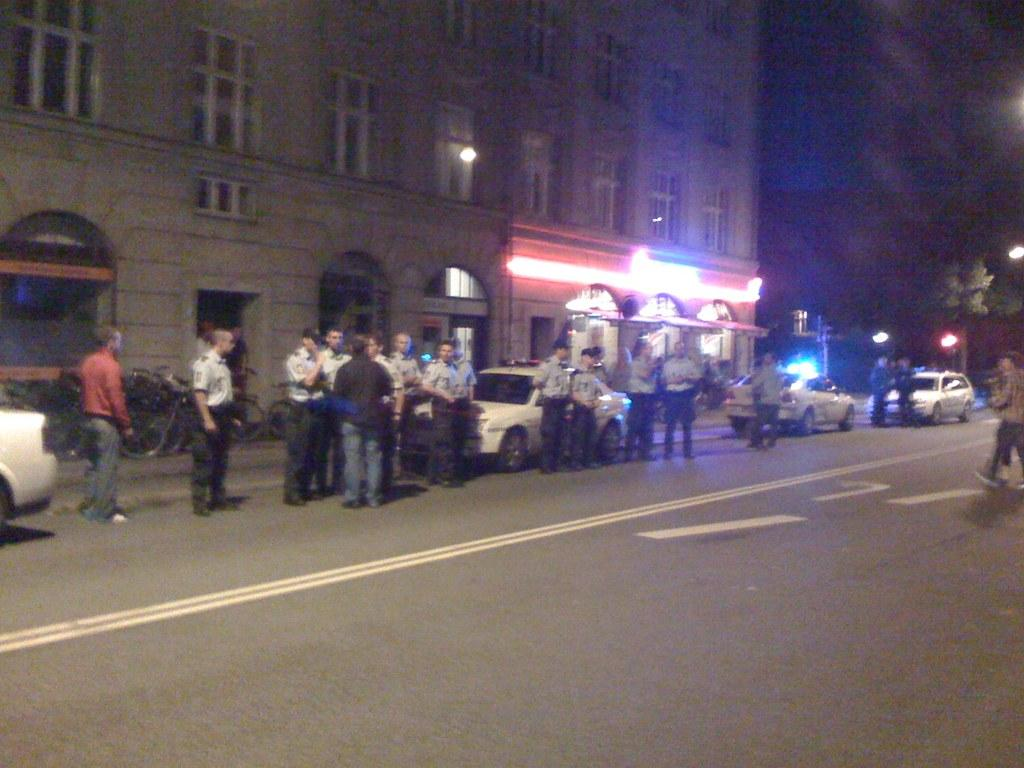What are the people in the image doing? The people in the image are standing on a road. What is behind the people? There are cars behind the people. What can be seen in the background of the image? There is a building in the background. What type of record is being played in the image? There is no record present in the image. 